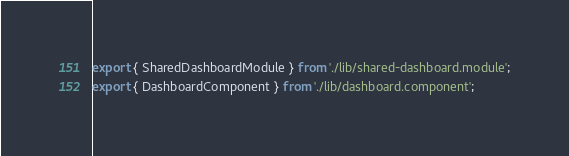<code> <loc_0><loc_0><loc_500><loc_500><_TypeScript_>export { SharedDashboardModule } from './lib/shared-dashboard.module';
export { DashboardComponent } from './lib/dashboard.component';
</code> 